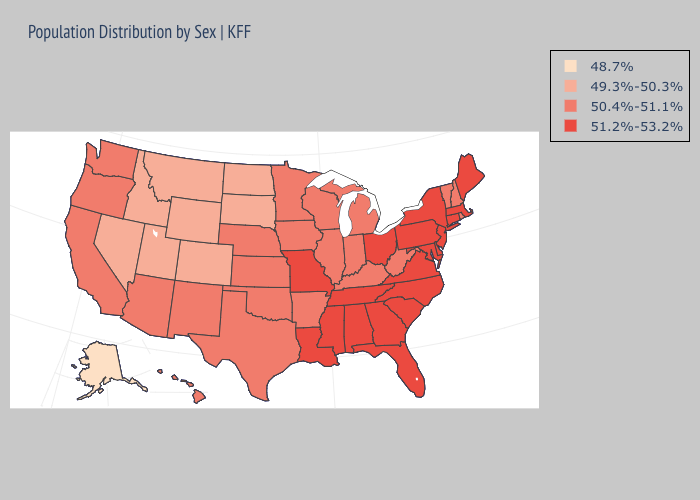Does Idaho have the highest value in the West?
Answer briefly. No. What is the value of Georgia?
Write a very short answer. 51.2%-53.2%. Does Kansas have the lowest value in the USA?
Give a very brief answer. No. Which states hav the highest value in the West?
Write a very short answer. Arizona, California, Hawaii, New Mexico, Oregon, Washington. Which states have the lowest value in the Northeast?
Write a very short answer. New Hampshire, Rhode Island, Vermont. What is the value of Texas?
Quick response, please. 50.4%-51.1%. Name the states that have a value in the range 50.4%-51.1%?
Answer briefly. Arizona, Arkansas, California, Hawaii, Illinois, Indiana, Iowa, Kansas, Kentucky, Michigan, Minnesota, Nebraska, New Hampshire, New Mexico, Oklahoma, Oregon, Rhode Island, Texas, Vermont, Washington, West Virginia, Wisconsin. Name the states that have a value in the range 50.4%-51.1%?
Short answer required. Arizona, Arkansas, California, Hawaii, Illinois, Indiana, Iowa, Kansas, Kentucky, Michigan, Minnesota, Nebraska, New Hampshire, New Mexico, Oklahoma, Oregon, Rhode Island, Texas, Vermont, Washington, West Virginia, Wisconsin. Does Utah have the highest value in the West?
Keep it brief. No. Name the states that have a value in the range 51.2%-53.2%?
Answer briefly. Alabama, Connecticut, Delaware, Florida, Georgia, Louisiana, Maine, Maryland, Massachusetts, Mississippi, Missouri, New Jersey, New York, North Carolina, Ohio, Pennsylvania, South Carolina, Tennessee, Virginia. What is the value of Massachusetts?
Give a very brief answer. 51.2%-53.2%. 